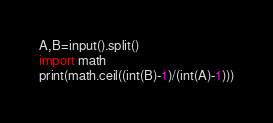Convert code to text. <code><loc_0><loc_0><loc_500><loc_500><_Python_>A,B=input().split()
import math
print(math.ceil((int(B)-1)/(int(A)-1)))</code> 